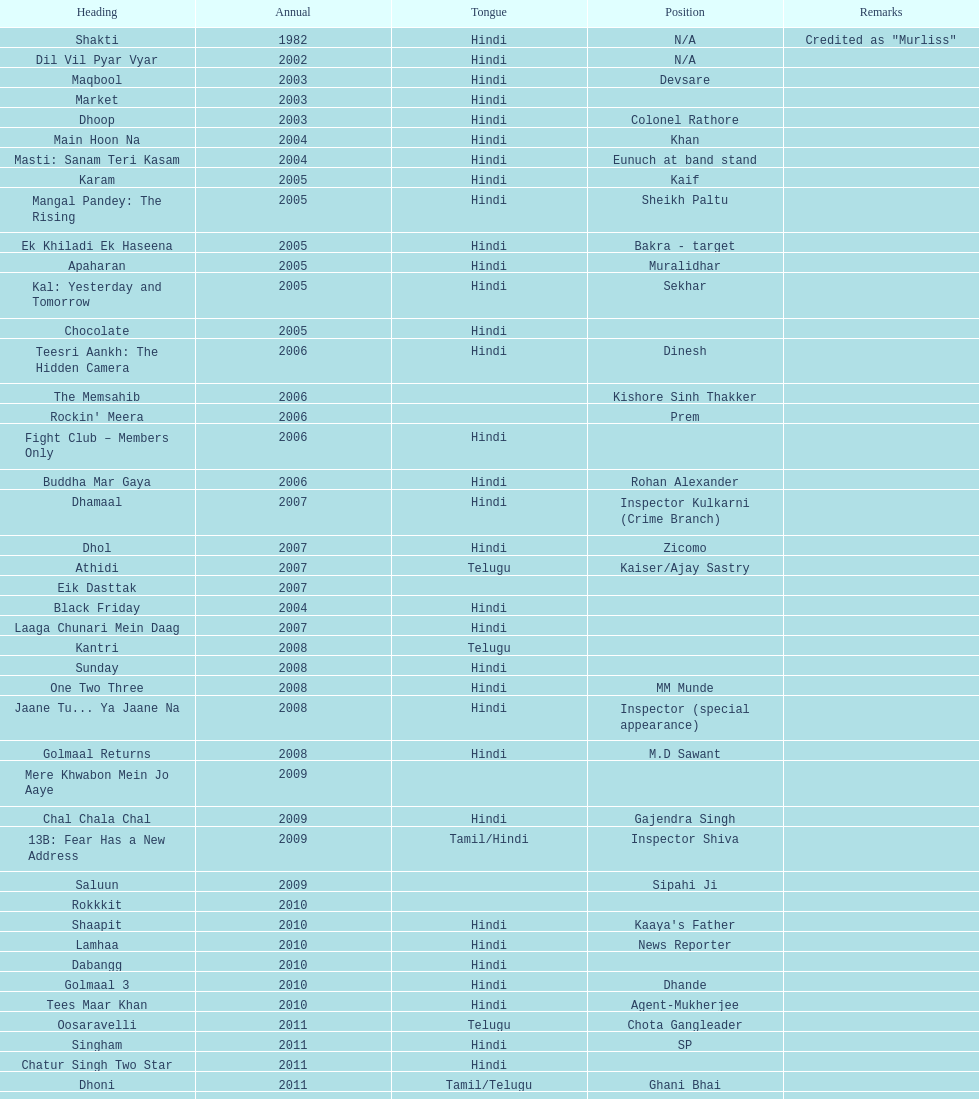What is the total years on the chart 13. 